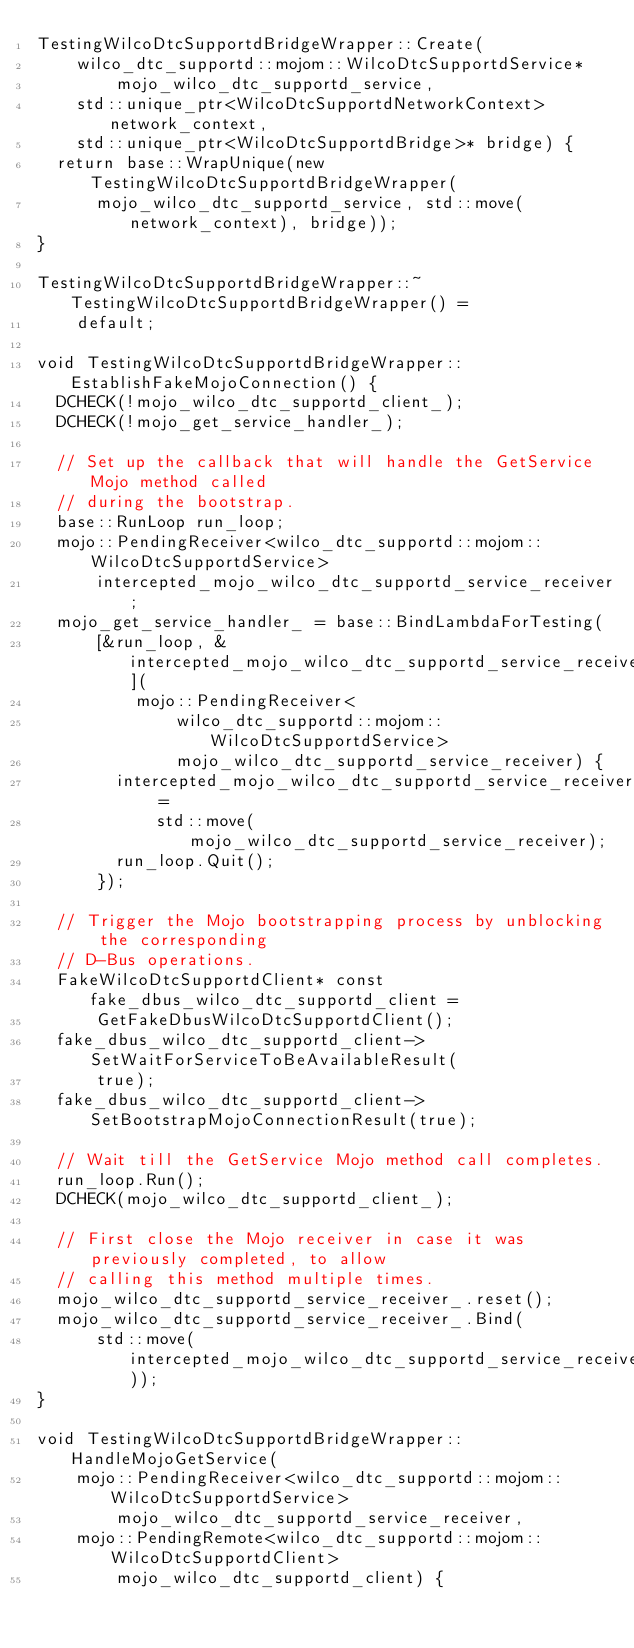<code> <loc_0><loc_0><loc_500><loc_500><_C++_>TestingWilcoDtcSupportdBridgeWrapper::Create(
    wilco_dtc_supportd::mojom::WilcoDtcSupportdService*
        mojo_wilco_dtc_supportd_service,
    std::unique_ptr<WilcoDtcSupportdNetworkContext> network_context,
    std::unique_ptr<WilcoDtcSupportdBridge>* bridge) {
  return base::WrapUnique(new TestingWilcoDtcSupportdBridgeWrapper(
      mojo_wilco_dtc_supportd_service, std::move(network_context), bridge));
}

TestingWilcoDtcSupportdBridgeWrapper::~TestingWilcoDtcSupportdBridgeWrapper() =
    default;

void TestingWilcoDtcSupportdBridgeWrapper::EstablishFakeMojoConnection() {
  DCHECK(!mojo_wilco_dtc_supportd_client_);
  DCHECK(!mojo_get_service_handler_);

  // Set up the callback that will handle the GetService Mojo method called
  // during the bootstrap.
  base::RunLoop run_loop;
  mojo::PendingReceiver<wilco_dtc_supportd::mojom::WilcoDtcSupportdService>
      intercepted_mojo_wilco_dtc_supportd_service_receiver;
  mojo_get_service_handler_ = base::BindLambdaForTesting(
      [&run_loop, &intercepted_mojo_wilco_dtc_supportd_service_receiver](
          mojo::PendingReceiver<
              wilco_dtc_supportd::mojom::WilcoDtcSupportdService>
              mojo_wilco_dtc_supportd_service_receiver) {
        intercepted_mojo_wilco_dtc_supportd_service_receiver =
            std::move(mojo_wilco_dtc_supportd_service_receiver);
        run_loop.Quit();
      });

  // Trigger the Mojo bootstrapping process by unblocking the corresponding
  // D-Bus operations.
  FakeWilcoDtcSupportdClient* const fake_dbus_wilco_dtc_supportd_client =
      GetFakeDbusWilcoDtcSupportdClient();
  fake_dbus_wilco_dtc_supportd_client->SetWaitForServiceToBeAvailableResult(
      true);
  fake_dbus_wilco_dtc_supportd_client->SetBootstrapMojoConnectionResult(true);

  // Wait till the GetService Mojo method call completes.
  run_loop.Run();
  DCHECK(mojo_wilco_dtc_supportd_client_);

  // First close the Mojo receiver in case it was previously completed, to allow
  // calling this method multiple times.
  mojo_wilco_dtc_supportd_service_receiver_.reset();
  mojo_wilco_dtc_supportd_service_receiver_.Bind(
      std::move(intercepted_mojo_wilco_dtc_supportd_service_receiver));
}

void TestingWilcoDtcSupportdBridgeWrapper::HandleMojoGetService(
    mojo::PendingReceiver<wilco_dtc_supportd::mojom::WilcoDtcSupportdService>
        mojo_wilco_dtc_supportd_service_receiver,
    mojo::PendingRemote<wilco_dtc_supportd::mojom::WilcoDtcSupportdClient>
        mojo_wilco_dtc_supportd_client) {</code> 